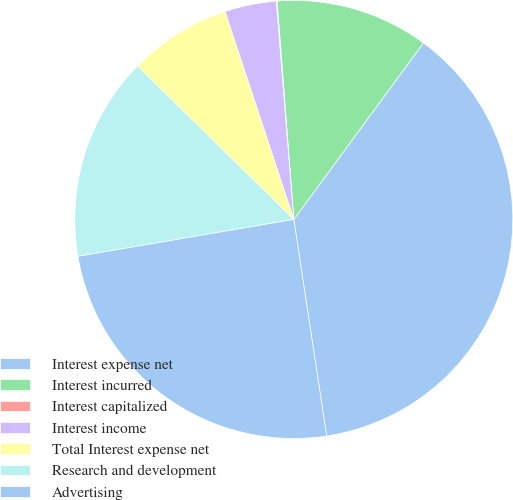Convert chart to OTSL. <chart><loc_0><loc_0><loc_500><loc_500><pie_chart><fcel>Interest expense net<fcel>Interest incurred<fcel>Interest capitalized<fcel>Interest income<fcel>Total Interest expense net<fcel>Research and development<fcel>Advertising<nl><fcel>37.52%<fcel>11.3%<fcel>0.06%<fcel>3.81%<fcel>7.56%<fcel>15.05%<fcel>24.7%<nl></chart> 